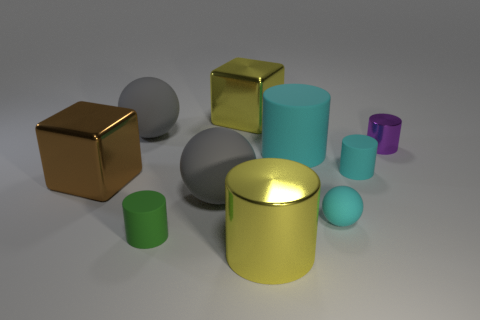Subtract 2 cylinders. How many cylinders are left? 3 Subtract all purple cylinders. How many cylinders are left? 4 Subtract all big cyan matte cylinders. How many cylinders are left? 4 Subtract all brown cylinders. Subtract all gray spheres. How many cylinders are left? 5 Subtract all blocks. How many objects are left? 8 Add 6 yellow rubber spheres. How many yellow rubber spheres exist? 6 Subtract 1 green cylinders. How many objects are left? 9 Subtract all purple metal cylinders. Subtract all tiny matte objects. How many objects are left? 6 Add 4 large yellow shiny blocks. How many large yellow shiny blocks are left? 5 